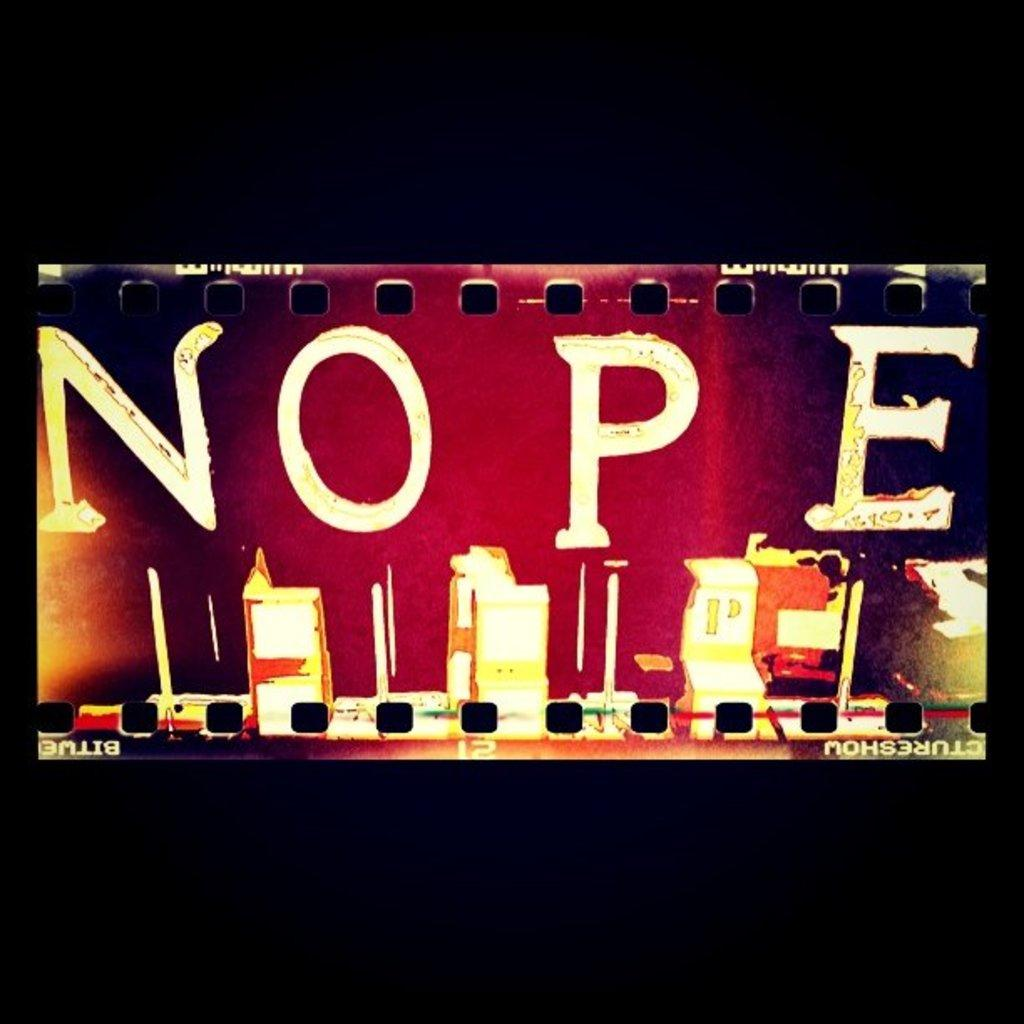<image>
Write a terse but informative summary of the picture. a candlelit area that has the word nope on it 